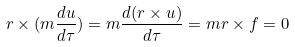<formula> <loc_0><loc_0><loc_500><loc_500>r \times ( m \frac { d u } { d \tau } ) = m \frac { d ( r \times u ) } { d \tau } = m r \times f = 0</formula> 